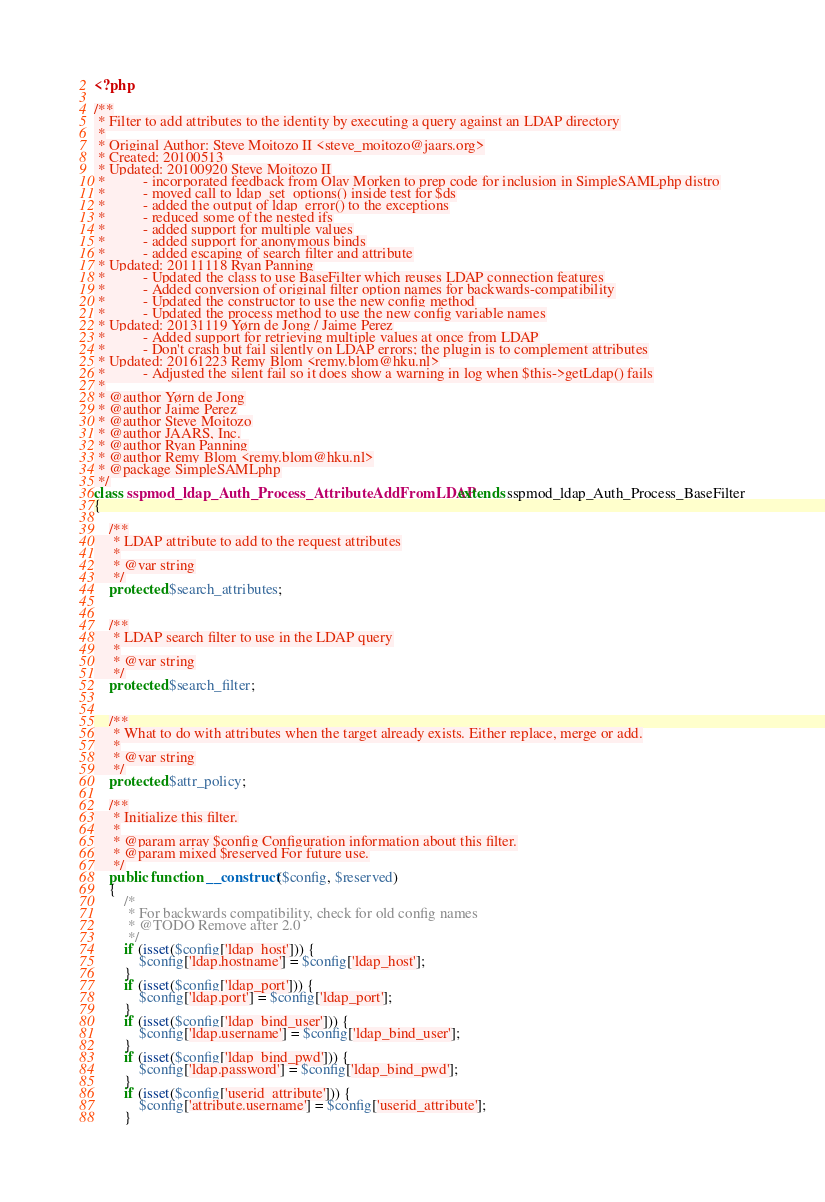Convert code to text. <code><loc_0><loc_0><loc_500><loc_500><_PHP_><?php

/**
 * Filter to add attributes to the identity by executing a query against an LDAP directory
 *
 * Original Author: Steve Moitozo II <steve_moitozo@jaars.org>
 * Created: 20100513
 * Updated: 20100920 Steve Moitozo II
 *          - incorporated feedback from Olav Morken to prep code for inclusion in SimpleSAMLphp distro
 *          - moved call to ldap_set_options() inside test for $ds
 *          - added the output of ldap_error() to the exceptions
 *          - reduced some of the nested ifs
 *          - added support for multiple values
 *          - added support for anonymous binds
 *          - added escaping of search filter and attribute
 * Updated: 20111118 Ryan Panning
 *          - Updated the class to use BaseFilter which reuses LDAP connection features
 *          - Added conversion of original filter option names for backwards-compatibility
 *          - Updated the constructor to use the new config method
 *          - Updated the process method to use the new config variable names
 * Updated: 20131119 Yørn de Jong / Jaime Perez
 *          - Added support for retrieving multiple values at once from LDAP
 *          - Don't crash but fail silently on LDAP errors; the plugin is to complement attributes
 * Updated: 20161223 Remy Blom <remy.blom@hku.nl>
 *          - Adjusted the silent fail so it does show a warning in log when $this->getLdap() fails
 *
 * @author Yørn de Jong
 * @author Jaime Perez
 * @author Steve Moitozo
 * @author JAARS, Inc.
 * @author Ryan Panning
 * @author Remy Blom <remy.blom@hku.nl>
 * @package SimpleSAMLphp
 */
class sspmod_ldap_Auth_Process_AttributeAddFromLDAP extends sspmod_ldap_Auth_Process_BaseFilter
{

    /**
     * LDAP attribute to add to the request attributes
     *
     * @var string
     */
    protected $search_attributes;


    /**
     * LDAP search filter to use in the LDAP query
     *
     * @var string
     */
    protected $search_filter;


    /**
     * What to do with attributes when the target already exists. Either replace, merge or add.
     *
     * @var string
     */
    protected $attr_policy;

    /**
     * Initialize this filter.
     *
     * @param array $config Configuration information about this filter.
     * @param mixed $reserved For future use.
     */
    public function __construct($config, $reserved)
    {
        /*
         * For backwards compatibility, check for old config names
         * @TODO Remove after 2.0
         */
        if (isset($config['ldap_host'])) {
            $config['ldap.hostname'] = $config['ldap_host'];
        }
        if (isset($config['ldap_port'])) {
            $config['ldap.port'] = $config['ldap_port'];
        }
        if (isset($config['ldap_bind_user'])) {
            $config['ldap.username'] = $config['ldap_bind_user'];
        }
        if (isset($config['ldap_bind_pwd'])) {
            $config['ldap.password'] = $config['ldap_bind_pwd'];
        }
        if (isset($config['userid_attribute'])) {
            $config['attribute.username'] = $config['userid_attribute'];
        }</code> 